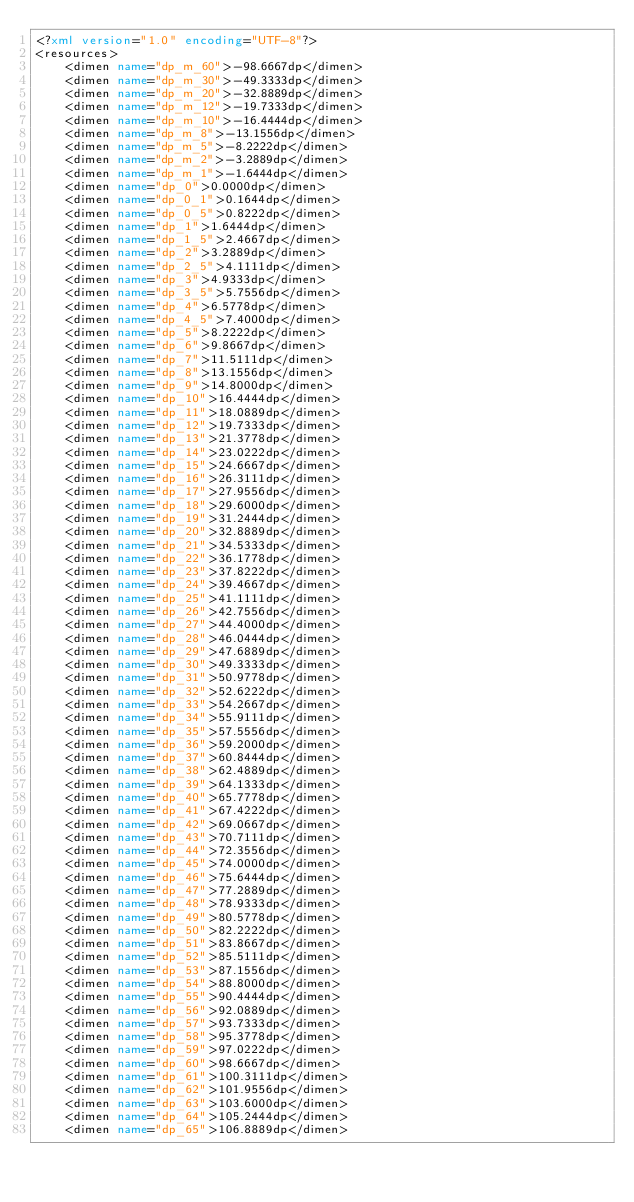Convert code to text. <code><loc_0><loc_0><loc_500><loc_500><_XML_><?xml version="1.0" encoding="UTF-8"?>
<resources>
	<dimen name="dp_m_60">-98.6667dp</dimen>
	<dimen name="dp_m_30">-49.3333dp</dimen>
	<dimen name="dp_m_20">-32.8889dp</dimen>
	<dimen name="dp_m_12">-19.7333dp</dimen>
	<dimen name="dp_m_10">-16.4444dp</dimen>
	<dimen name="dp_m_8">-13.1556dp</dimen>
	<dimen name="dp_m_5">-8.2222dp</dimen>
	<dimen name="dp_m_2">-3.2889dp</dimen>
	<dimen name="dp_m_1">-1.6444dp</dimen>
	<dimen name="dp_0">0.0000dp</dimen>
	<dimen name="dp_0_1">0.1644dp</dimen>
	<dimen name="dp_0_5">0.8222dp</dimen>
	<dimen name="dp_1">1.6444dp</dimen>
	<dimen name="dp_1_5">2.4667dp</dimen>
	<dimen name="dp_2">3.2889dp</dimen>
	<dimen name="dp_2_5">4.1111dp</dimen>
	<dimen name="dp_3">4.9333dp</dimen>
	<dimen name="dp_3_5">5.7556dp</dimen>
	<dimen name="dp_4">6.5778dp</dimen>
	<dimen name="dp_4_5">7.4000dp</dimen>
	<dimen name="dp_5">8.2222dp</dimen>
	<dimen name="dp_6">9.8667dp</dimen>
	<dimen name="dp_7">11.5111dp</dimen>
	<dimen name="dp_8">13.1556dp</dimen>
	<dimen name="dp_9">14.8000dp</dimen>
	<dimen name="dp_10">16.4444dp</dimen>
	<dimen name="dp_11">18.0889dp</dimen>
	<dimen name="dp_12">19.7333dp</dimen>
	<dimen name="dp_13">21.3778dp</dimen>
	<dimen name="dp_14">23.0222dp</dimen>
	<dimen name="dp_15">24.6667dp</dimen>
	<dimen name="dp_16">26.3111dp</dimen>
	<dimen name="dp_17">27.9556dp</dimen>
	<dimen name="dp_18">29.6000dp</dimen>
	<dimen name="dp_19">31.2444dp</dimen>
	<dimen name="dp_20">32.8889dp</dimen>
	<dimen name="dp_21">34.5333dp</dimen>
	<dimen name="dp_22">36.1778dp</dimen>
	<dimen name="dp_23">37.8222dp</dimen>
	<dimen name="dp_24">39.4667dp</dimen>
	<dimen name="dp_25">41.1111dp</dimen>
	<dimen name="dp_26">42.7556dp</dimen>
	<dimen name="dp_27">44.4000dp</dimen>
	<dimen name="dp_28">46.0444dp</dimen>
	<dimen name="dp_29">47.6889dp</dimen>
	<dimen name="dp_30">49.3333dp</dimen>
	<dimen name="dp_31">50.9778dp</dimen>
	<dimen name="dp_32">52.6222dp</dimen>
	<dimen name="dp_33">54.2667dp</dimen>
	<dimen name="dp_34">55.9111dp</dimen>
	<dimen name="dp_35">57.5556dp</dimen>
	<dimen name="dp_36">59.2000dp</dimen>
	<dimen name="dp_37">60.8444dp</dimen>
	<dimen name="dp_38">62.4889dp</dimen>
	<dimen name="dp_39">64.1333dp</dimen>
	<dimen name="dp_40">65.7778dp</dimen>
	<dimen name="dp_41">67.4222dp</dimen>
	<dimen name="dp_42">69.0667dp</dimen>
	<dimen name="dp_43">70.7111dp</dimen>
	<dimen name="dp_44">72.3556dp</dimen>
	<dimen name="dp_45">74.0000dp</dimen>
	<dimen name="dp_46">75.6444dp</dimen>
	<dimen name="dp_47">77.2889dp</dimen>
	<dimen name="dp_48">78.9333dp</dimen>
	<dimen name="dp_49">80.5778dp</dimen>
	<dimen name="dp_50">82.2222dp</dimen>
	<dimen name="dp_51">83.8667dp</dimen>
	<dimen name="dp_52">85.5111dp</dimen>
	<dimen name="dp_53">87.1556dp</dimen>
	<dimen name="dp_54">88.8000dp</dimen>
	<dimen name="dp_55">90.4444dp</dimen>
	<dimen name="dp_56">92.0889dp</dimen>
	<dimen name="dp_57">93.7333dp</dimen>
	<dimen name="dp_58">95.3778dp</dimen>
	<dimen name="dp_59">97.0222dp</dimen>
	<dimen name="dp_60">98.6667dp</dimen>
	<dimen name="dp_61">100.3111dp</dimen>
	<dimen name="dp_62">101.9556dp</dimen>
	<dimen name="dp_63">103.6000dp</dimen>
	<dimen name="dp_64">105.2444dp</dimen>
	<dimen name="dp_65">106.8889dp</dimen></code> 